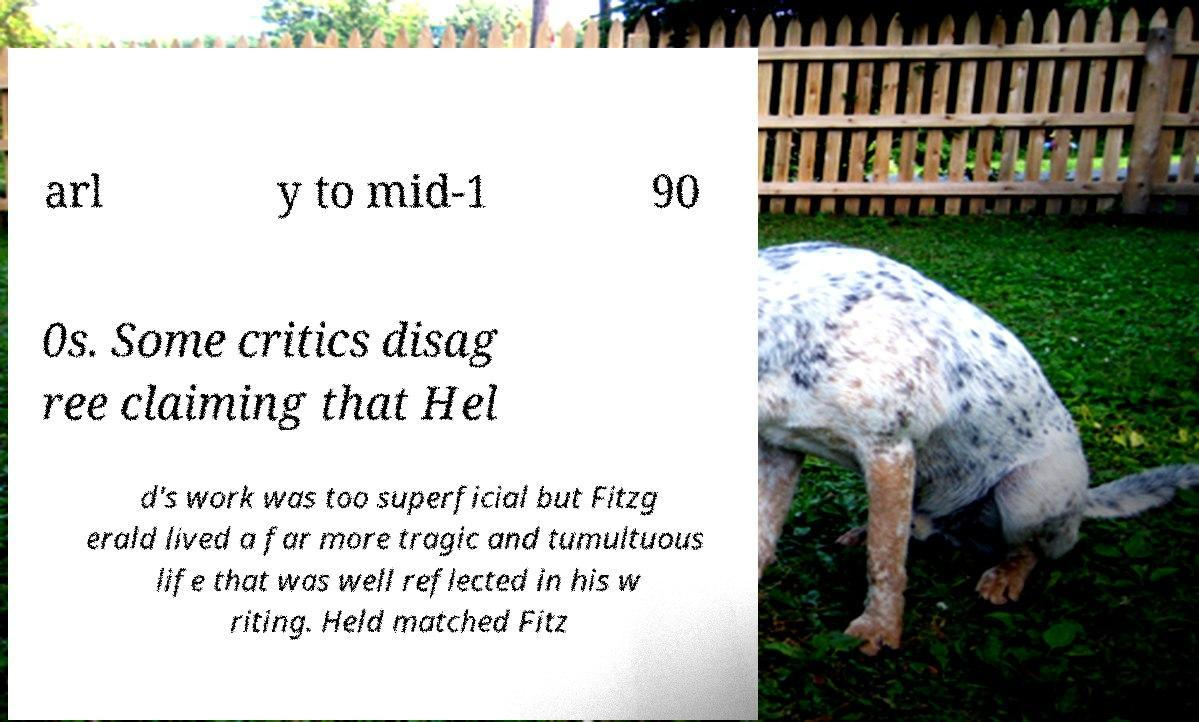Could you assist in decoding the text presented in this image and type it out clearly? arl y to mid-1 90 0s. Some critics disag ree claiming that Hel d's work was too superficial but Fitzg erald lived a far more tragic and tumultuous life that was well reflected in his w riting. Held matched Fitz 